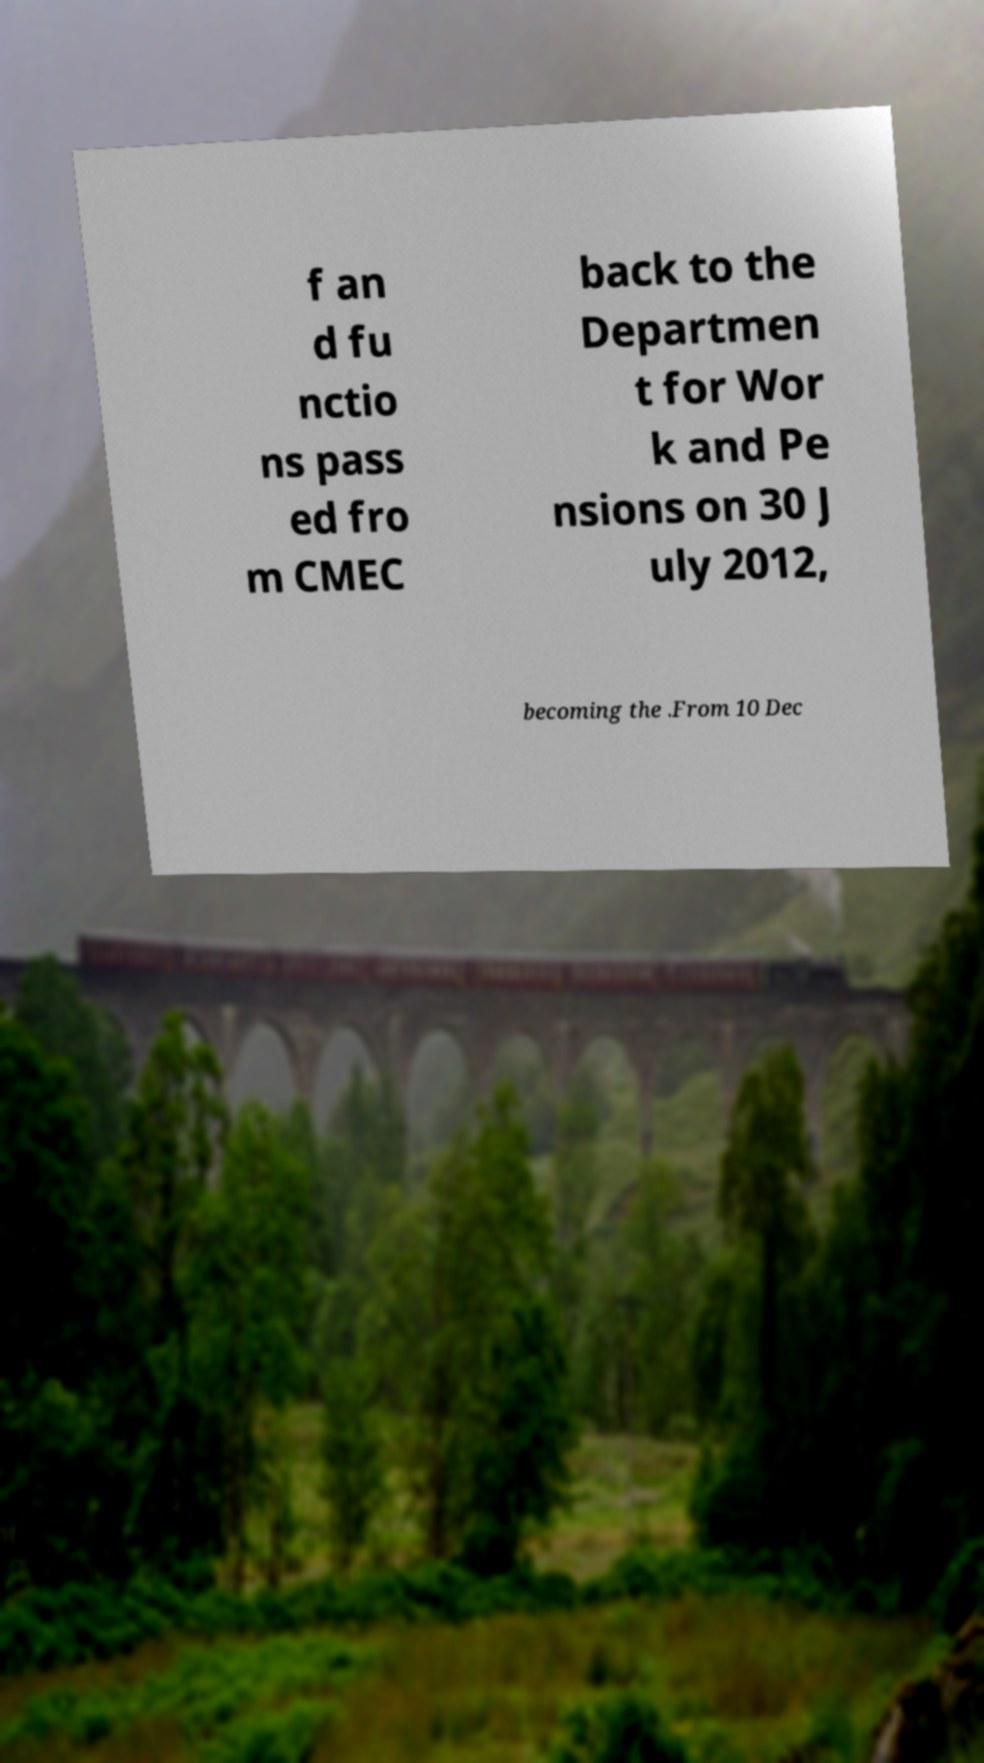Please identify and transcribe the text found in this image. f an d fu nctio ns pass ed fro m CMEC back to the Departmen t for Wor k and Pe nsions on 30 J uly 2012, becoming the .From 10 Dec 